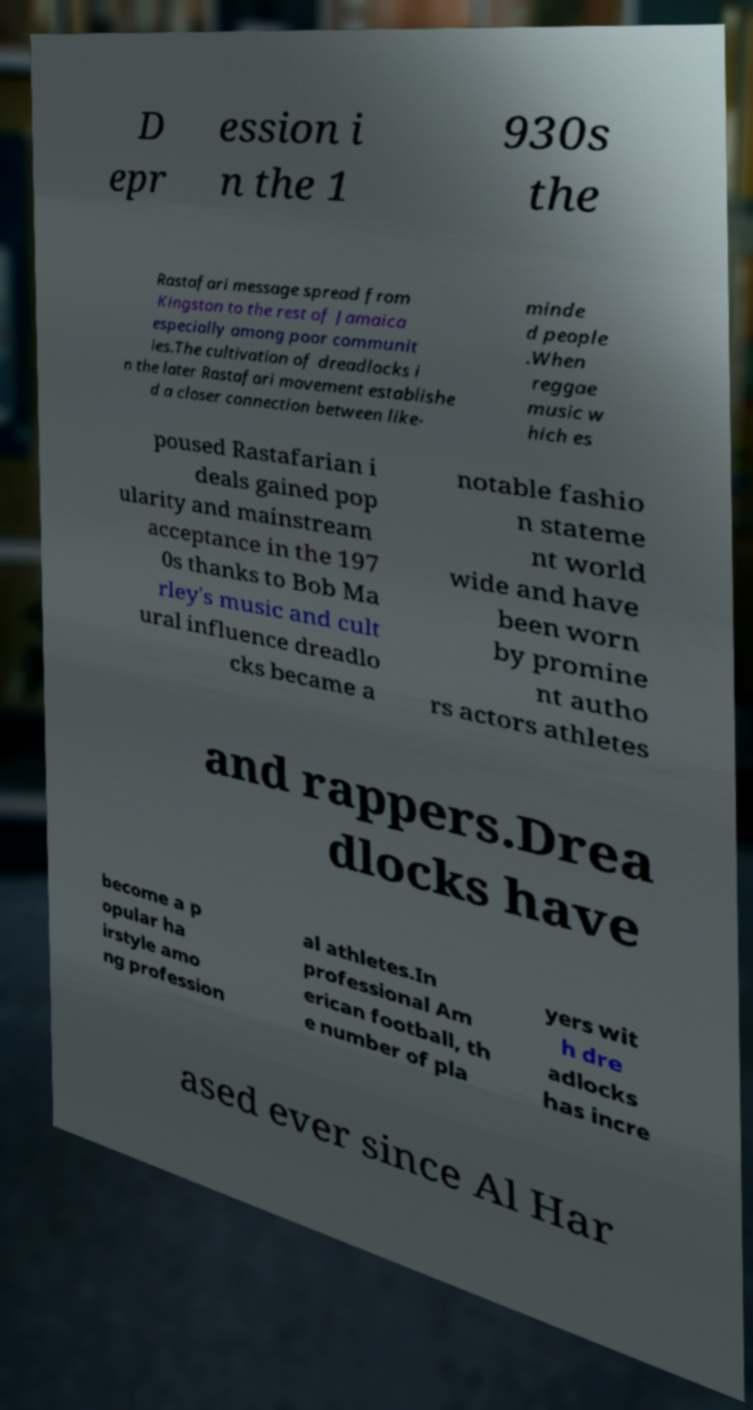Can you accurately transcribe the text from the provided image for me? D epr ession i n the 1 930s the Rastafari message spread from Kingston to the rest of Jamaica especially among poor communit ies.The cultivation of dreadlocks i n the later Rastafari movement establishe d a closer connection between like- minde d people .When reggae music w hich es poused Rastafarian i deals gained pop ularity and mainstream acceptance in the 197 0s thanks to Bob Ma rley's music and cult ural influence dreadlo cks became a notable fashio n stateme nt world wide and have been worn by promine nt autho rs actors athletes and rappers.Drea dlocks have become a p opular ha irstyle amo ng profession al athletes.In professional Am erican football, th e number of pla yers wit h dre adlocks has incre ased ever since Al Har 